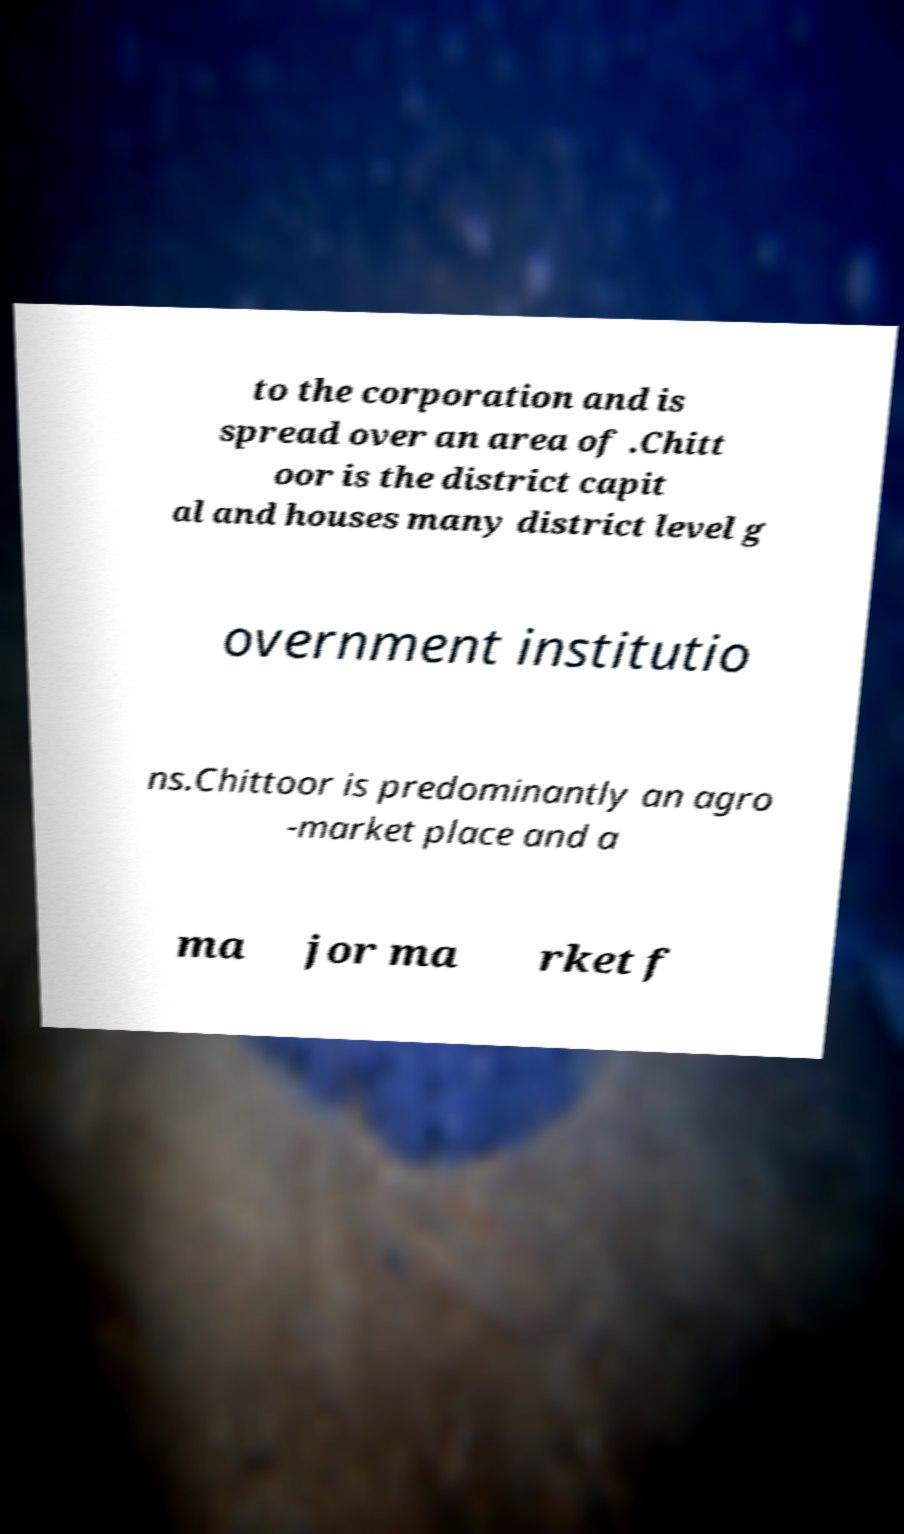There's text embedded in this image that I need extracted. Can you transcribe it verbatim? to the corporation and is spread over an area of .Chitt oor is the district capit al and houses many district level g overnment institutio ns.Chittoor is predominantly an agro -market place and a ma jor ma rket f 